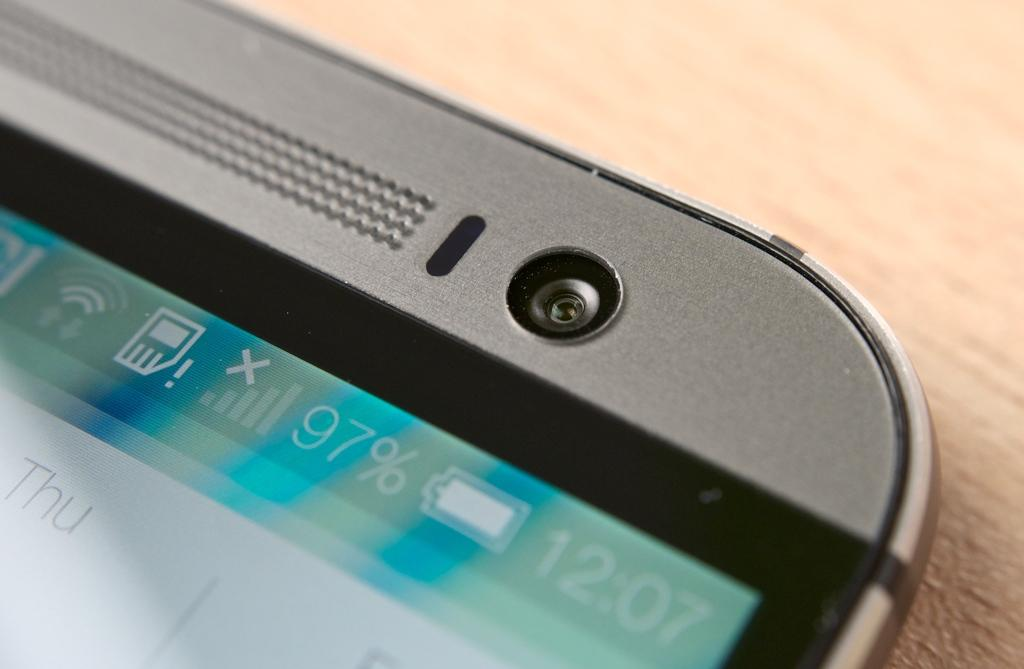Provide a one-sentence caption for the provided image. The top corner of a phone that is 97% charged. 